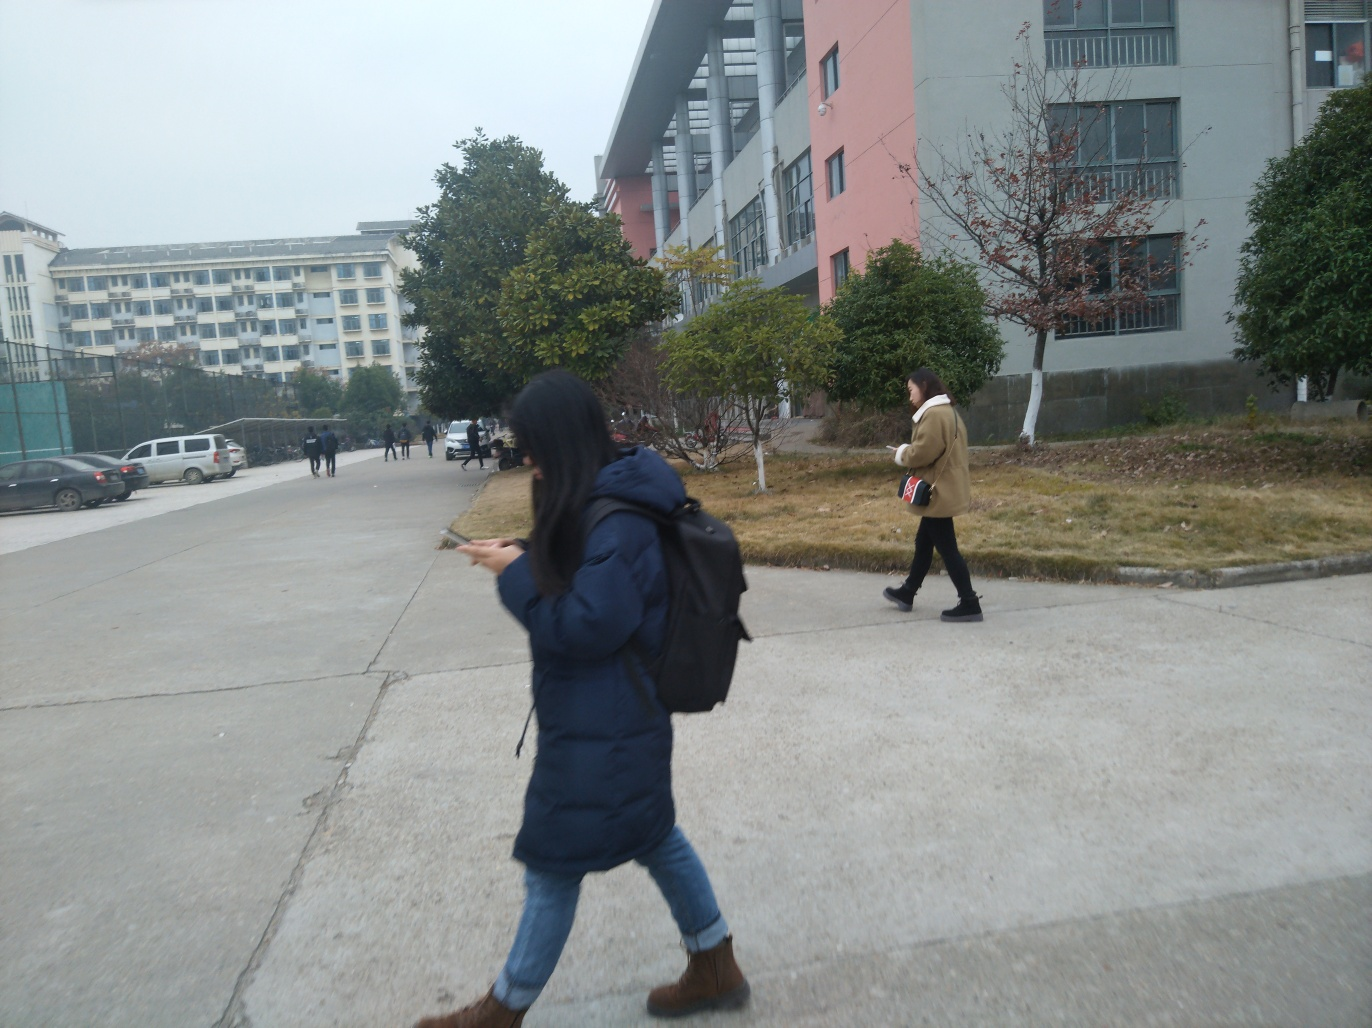What activities are the individuals in the image engaged in? The image captures one individual walking while engrossed in her mobile phone, likely texting or navigating, and the other person is walking with a focused pace carrying a book, signaling a possible intent to read or having just finished an academic session or study. 